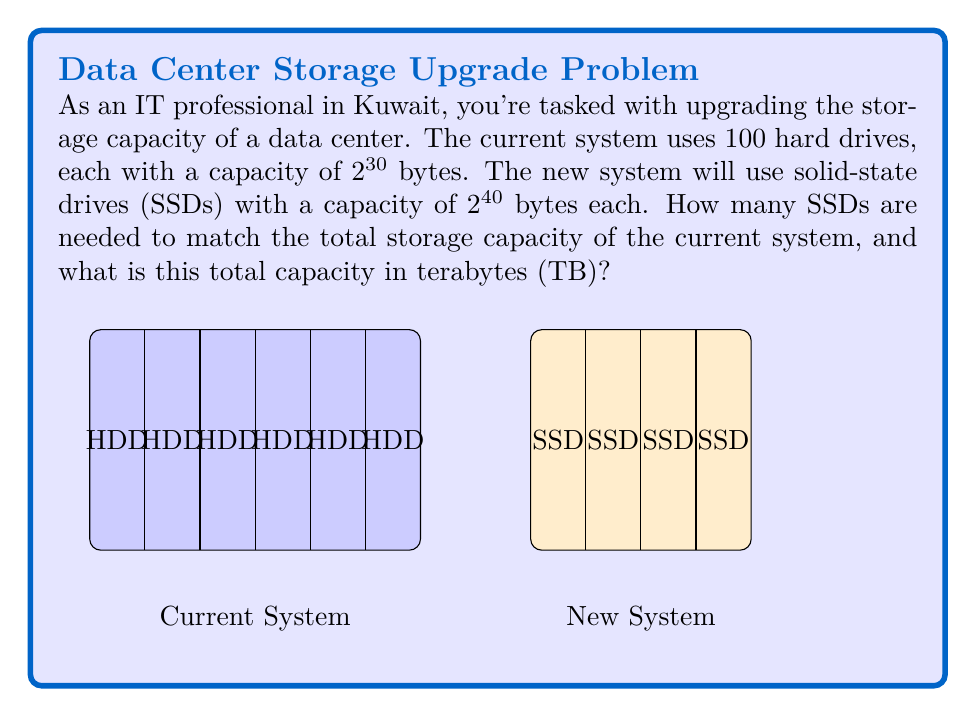Provide a solution to this math problem. Let's approach this step-by-step:

1) First, let's calculate the total storage capacity of the current system:
   - Each hard drive has $2^{30}$ bytes
   - There are 100 hard drives
   - Total capacity = $100 \times 2^{30}$ bytes

2) Now, let's find out how many SSDs are needed:
   - Total capacity needed = $100 \times 2^{30}$ bytes
   - Each SSD has $2^{40}$ bytes
   - Number of SSDs = $\frac{100 \times 2^{30}}{2^{40}} = 100 \times 2^{-10} = \frac{100}{1024} \approx 0.0977$

3) Since we can't use a fraction of an SSD, we need to round up to the nearest whole number. So we need 1 SSD.

4) Now, let's calculate the total capacity in terabytes:
   - Total capacity = $100 \times 2^{30}$ bytes
   - 1 TB = $2^{40}$ bytes
   - Capacity in TB = $\frac{100 \times 2^{30}}{2^{40}} = 100 \times 2^{-10} = \frac{100}{1024} \approx 0.0977$ TB

5) However, since we're using 1 full SSD, the actual capacity will be $2^{40}$ bytes or 1 TB.

Therefore, we need 1 SSD to match (and slightly exceed) the storage capacity of the current system, and the total capacity is 1 TB.
Answer: 1 SSD, 1 TB 